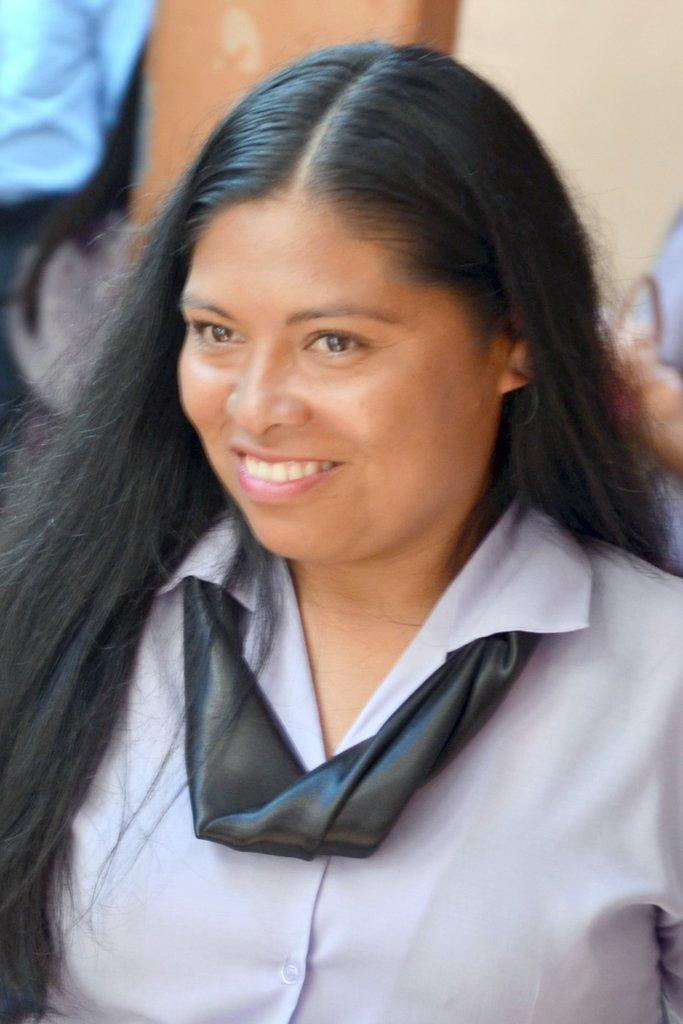Who is the main subject in the image? There is a lady in the image. What is the lady doing in the image? The lady is smiling in the image. Can you describe the background of the image? The background of the image is blurred. What type of line is being measured on the scale in the image? There is no line or scale present in the image; it features a lady smiling with a blurred background. 